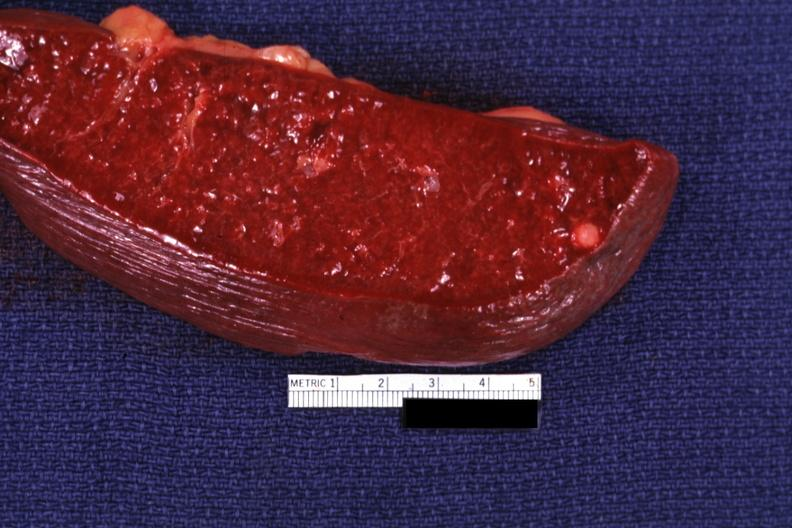s embryo-fetus present?
Answer the question using a single word or phrase. No 